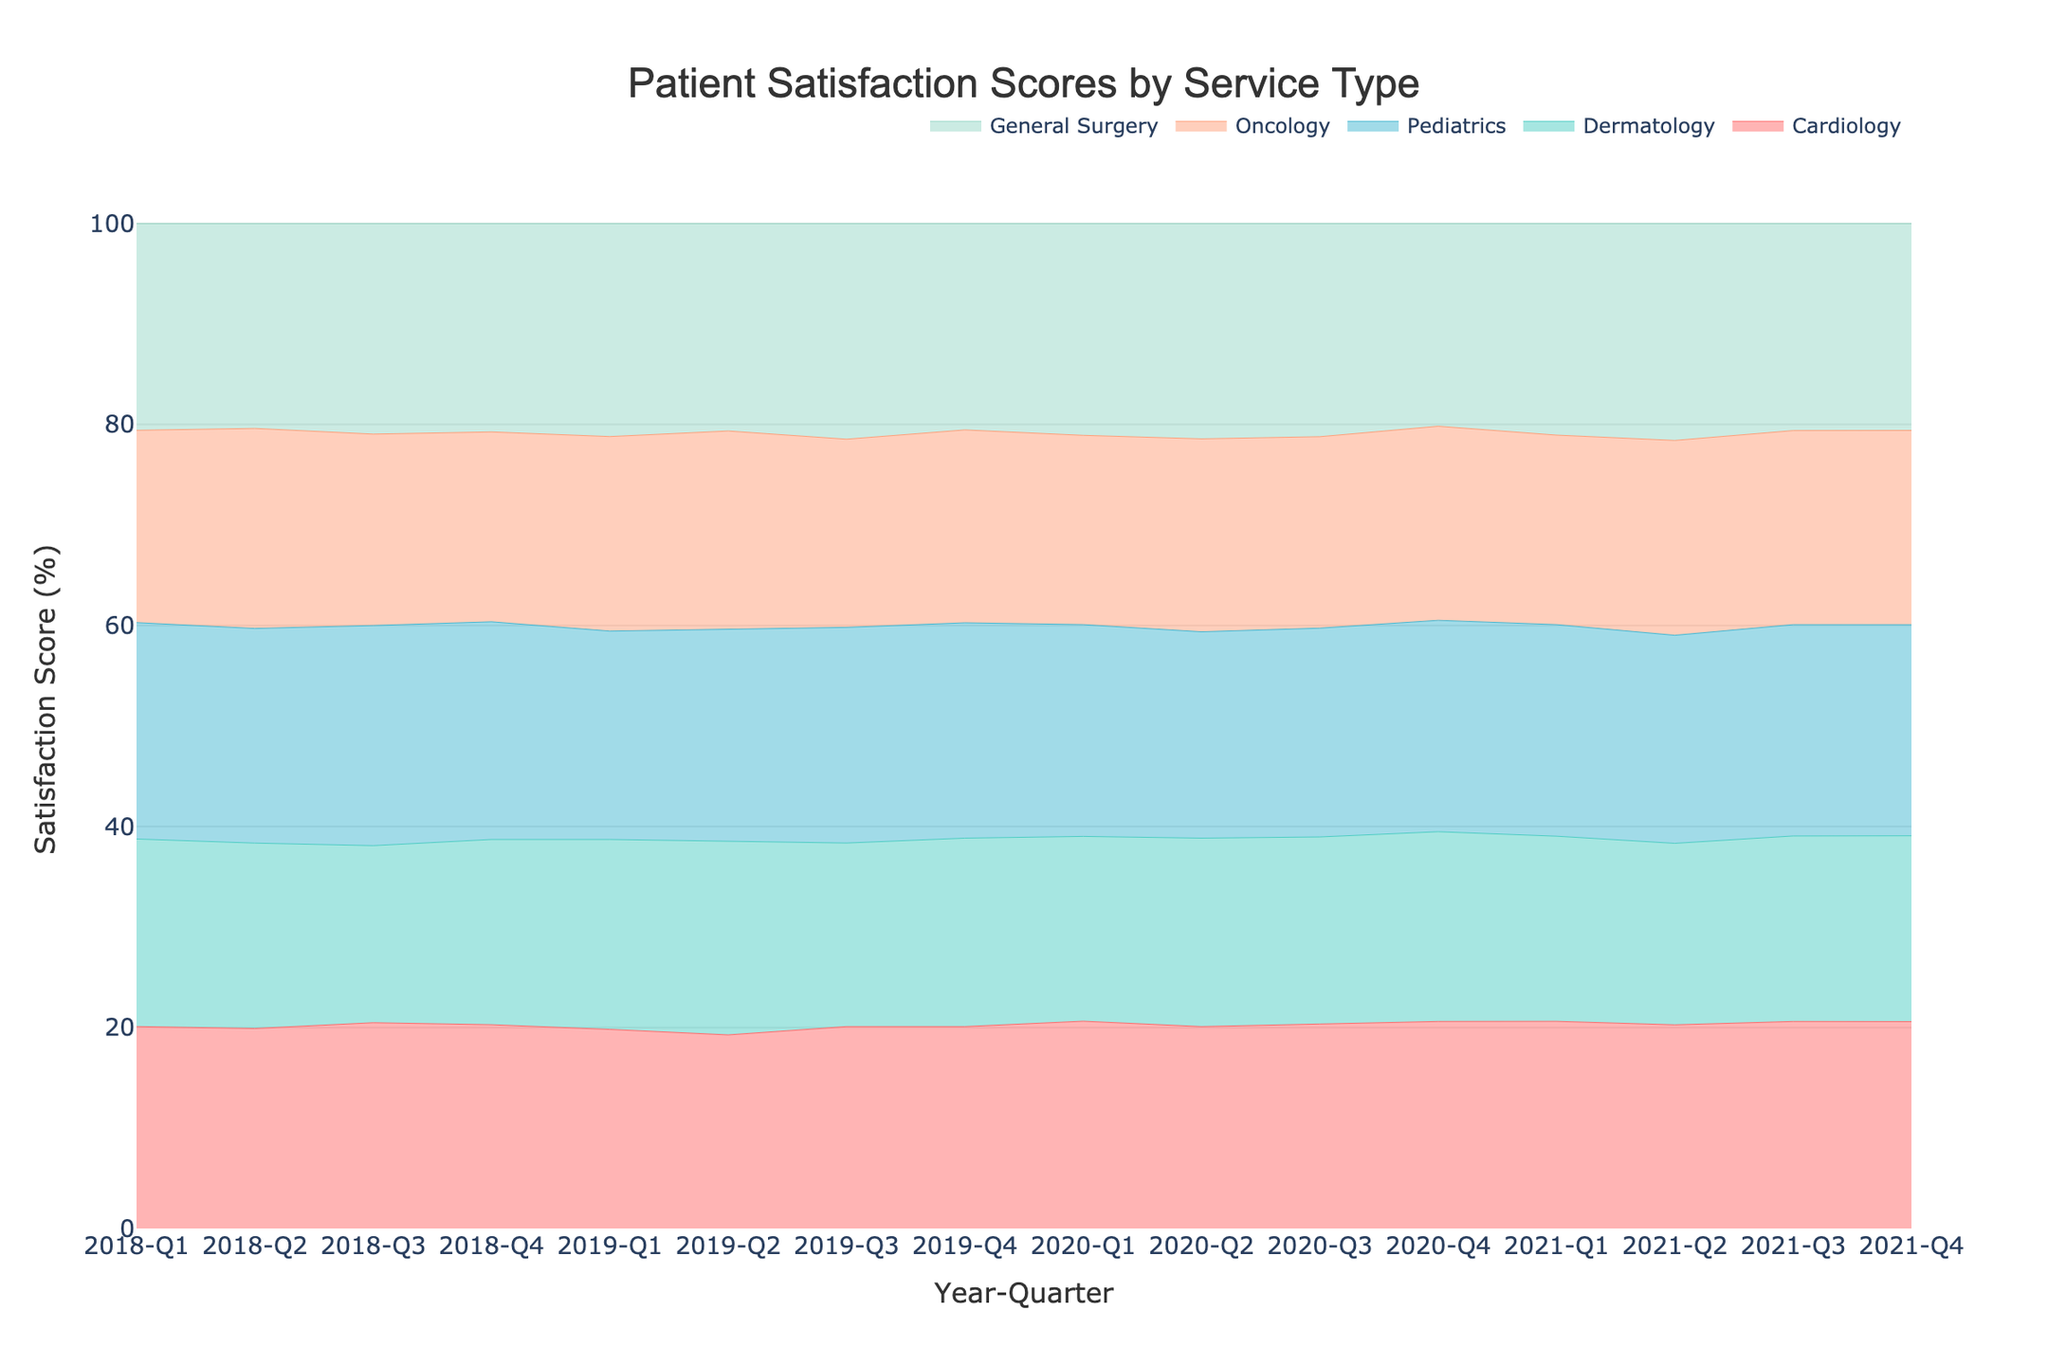what is the title of the figure? The title of the figure is prominently displayed at the top of the plot.
Answer: Patient Satisfaction Scores by Service Type What are the axes labels on the figure? The figure's axes labels can be found on the horizontal and vertical axes.
Answer: Year-Quarter and Satisfaction Score (%) Which service type had the highest satisfaction score in 2021-Q4? By examining the line plotted for each service type for the 2021-Q4 data point, the highest value should be identified.
Answer: Pediatrics Which quarter in 2020 showed the highest satisfaction score for Dermatology? Look along the x-axis for the quarters in 2020 and identify the highest plot point for Dermatology in that year.
Answer: 2020-Q4 What is the average satisfaction score for General Surgery across all the quarters? Add up the satisfaction scores for General Surgery for all the quarters and divide by the number of quarters. (4.3 + 4.2 + 4.4 + 4.5 + 4.6 + 4.5 + 4.7 + 4.6 + 4.7 + 4.8 + 4.9 + 4.7 + 4.8 + 4.9 + 4.8 + 4.9)/16 = 4.68
Answer: 4.68 Which service type showed the most improvement in satisfaction score from 2018-Q1 to 2021-Q4? Calculate the change in satisfaction score from 2018-Q1 to 2021-Q4 for each service type and determine which had the highest positive change.
Answer: Dermatology (3.9 to 4.4) How did the satisfaction score for Oncology change between 2018-Q1 and 2020-Q4? Compare the satisfaction score for Oncology at 2018-Q1 and 2020-Q4 to see the amount and direction of change.
Answer: Increased from 4.0 to 4.5 What is the overall trend for Pediatrics satisfaction scores from 2018 to 2021? Examine the plotted line for Pediatrics from the beginning to the end of the period to understand the general direction over time.
Answer: Increasing Which quarter in 2019 had the lowest satisfaction score for Cardiology? Identify the data points for Cardiology in 2019 and find the one with the lowest value.
Answer: 2019-Q2 During which period did General Surgery have its highest satisfaction score? Look at the plotted line for General Surgery to find the period with the highest value.
Answer: 2020-Q3 